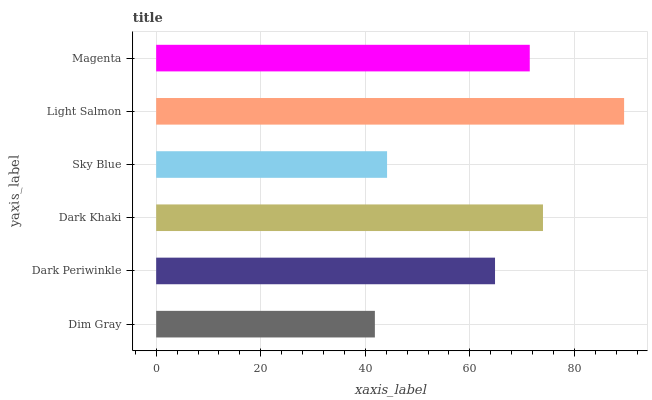Is Dim Gray the minimum?
Answer yes or no. Yes. Is Light Salmon the maximum?
Answer yes or no. Yes. Is Dark Periwinkle the minimum?
Answer yes or no. No. Is Dark Periwinkle the maximum?
Answer yes or no. No. Is Dark Periwinkle greater than Dim Gray?
Answer yes or no. Yes. Is Dim Gray less than Dark Periwinkle?
Answer yes or no. Yes. Is Dim Gray greater than Dark Periwinkle?
Answer yes or no. No. Is Dark Periwinkle less than Dim Gray?
Answer yes or no. No. Is Magenta the high median?
Answer yes or no. Yes. Is Dark Periwinkle the low median?
Answer yes or no. Yes. Is Light Salmon the high median?
Answer yes or no. No. Is Dim Gray the low median?
Answer yes or no. No. 